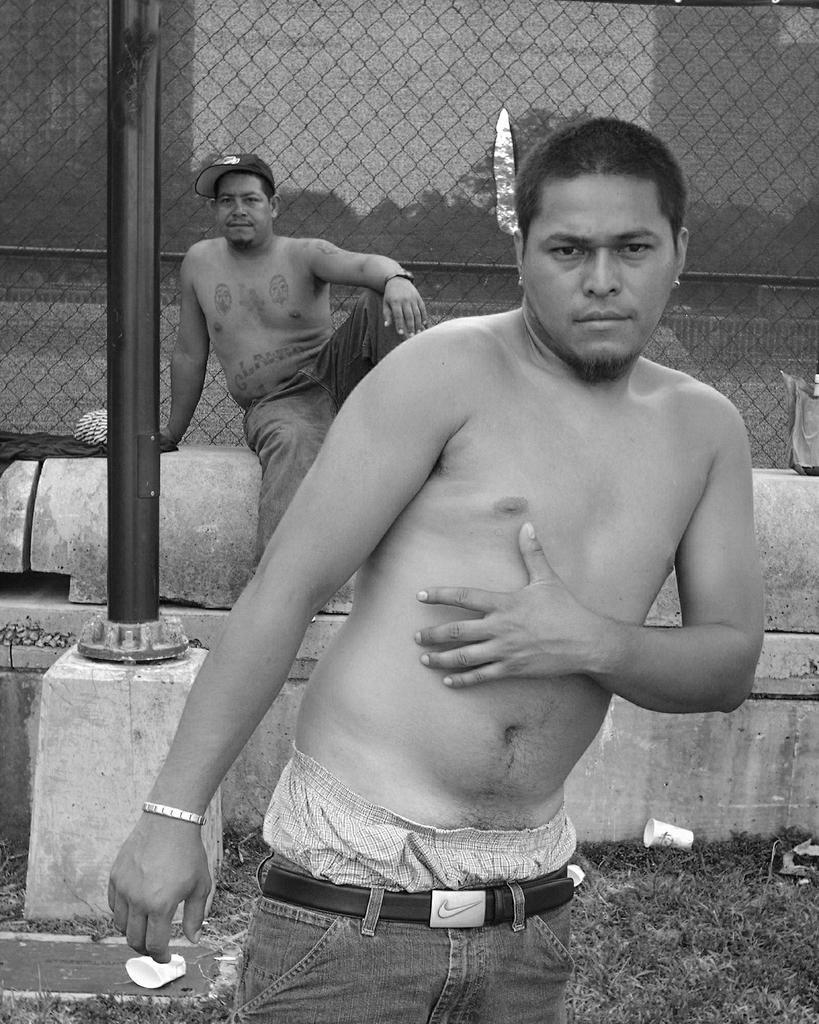Can you describe this image briefly? In the foreground of the image we can see a person standing. To the left side of the image we can see a pole placed on the ground. In the background we can see a person wearing cap is sitting on the wall in front of a iron fence. 